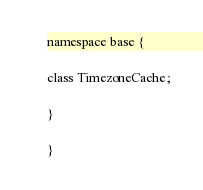Convert code to text. <code><loc_0><loc_0><loc_500><loc_500><_C_>
namespace base {

class TimezoneCache;

}

}</code> 